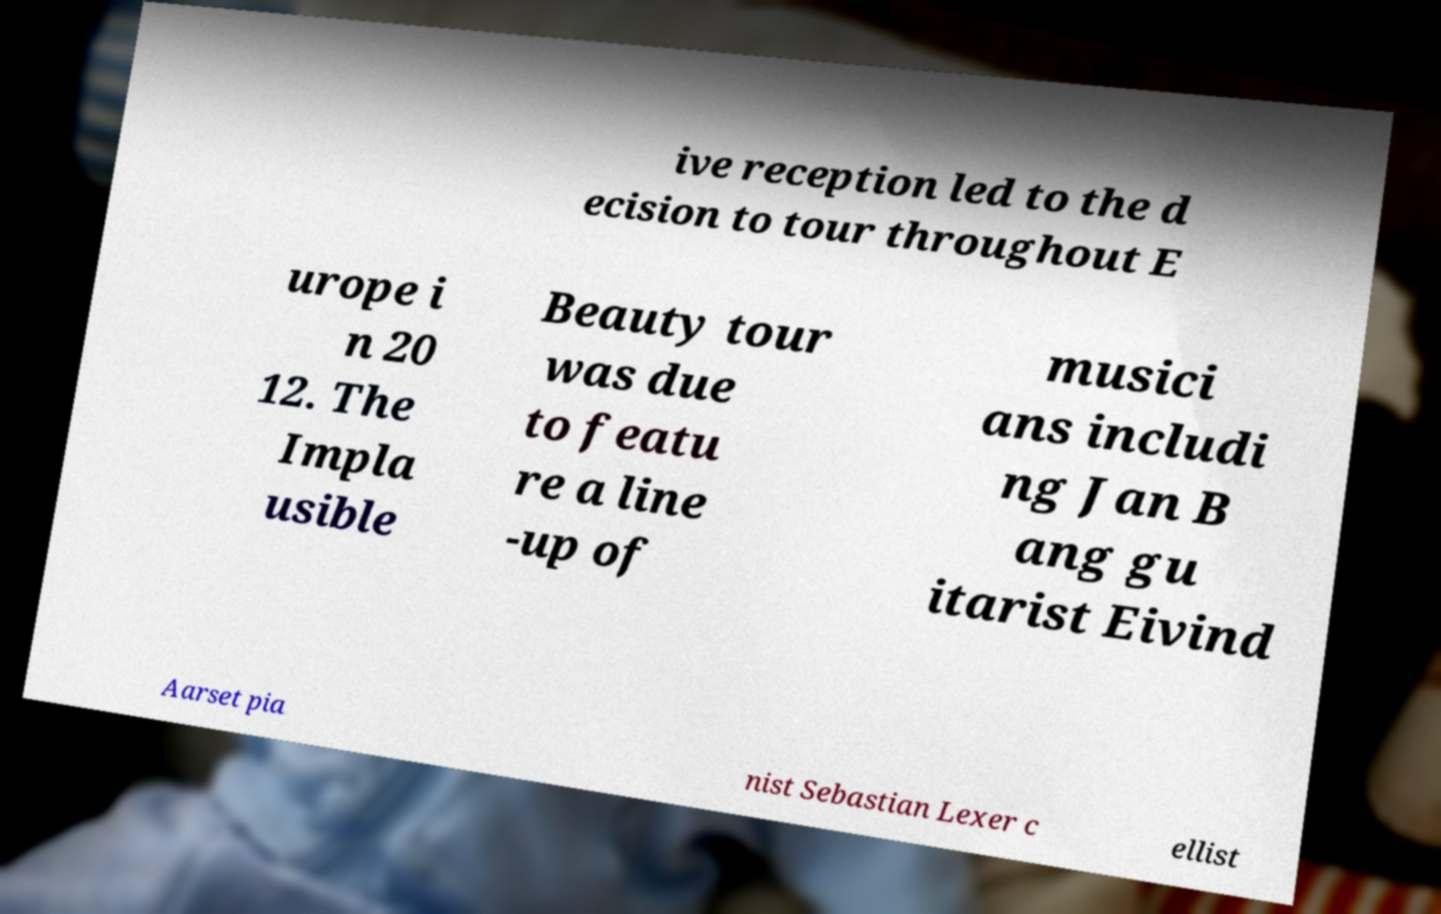Could you extract and type out the text from this image? ive reception led to the d ecision to tour throughout E urope i n 20 12. The Impla usible Beauty tour was due to featu re a line -up of musici ans includi ng Jan B ang gu itarist Eivind Aarset pia nist Sebastian Lexer c ellist 